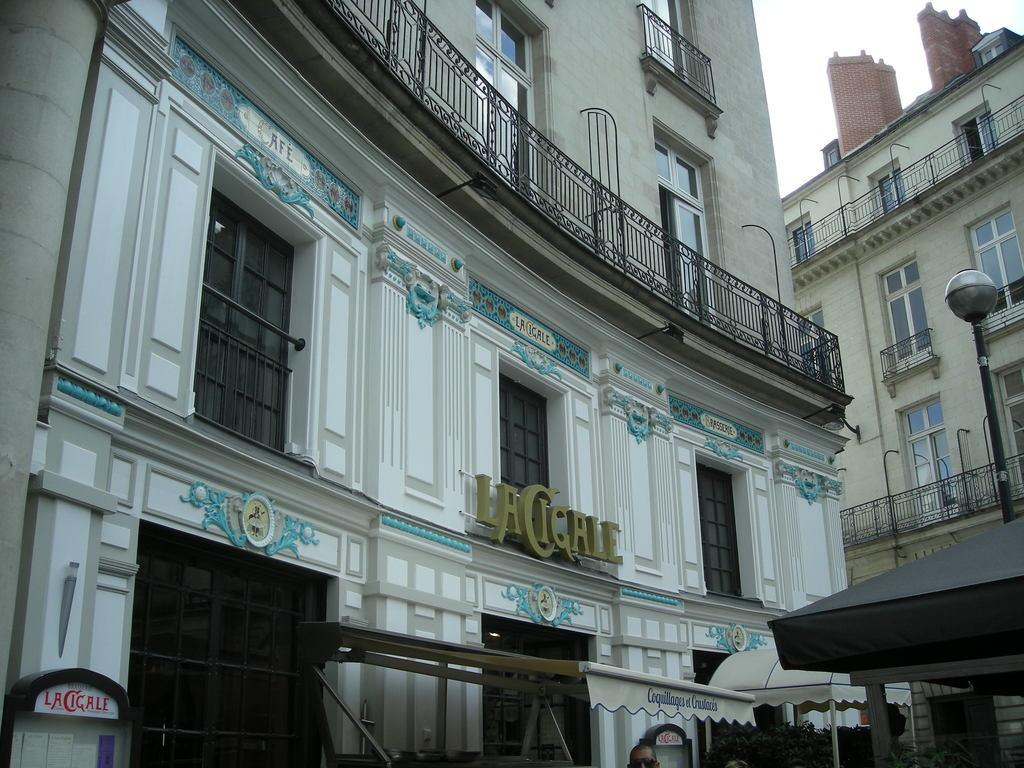What type of buildings can be seen in the image? There are buildings with glass windows in the image. Who or what can be seen at the bottom of the image? People and plants are visible at the bottom of the image. What is visible in the right top of the image? The sky is visible in the right top of the image. Where is the calculator located in the image? There is no calculator present in the image. What type of boot is being worn by the person in the image? There are no boots visible in the image, as people are not shown wearing any footwear. 